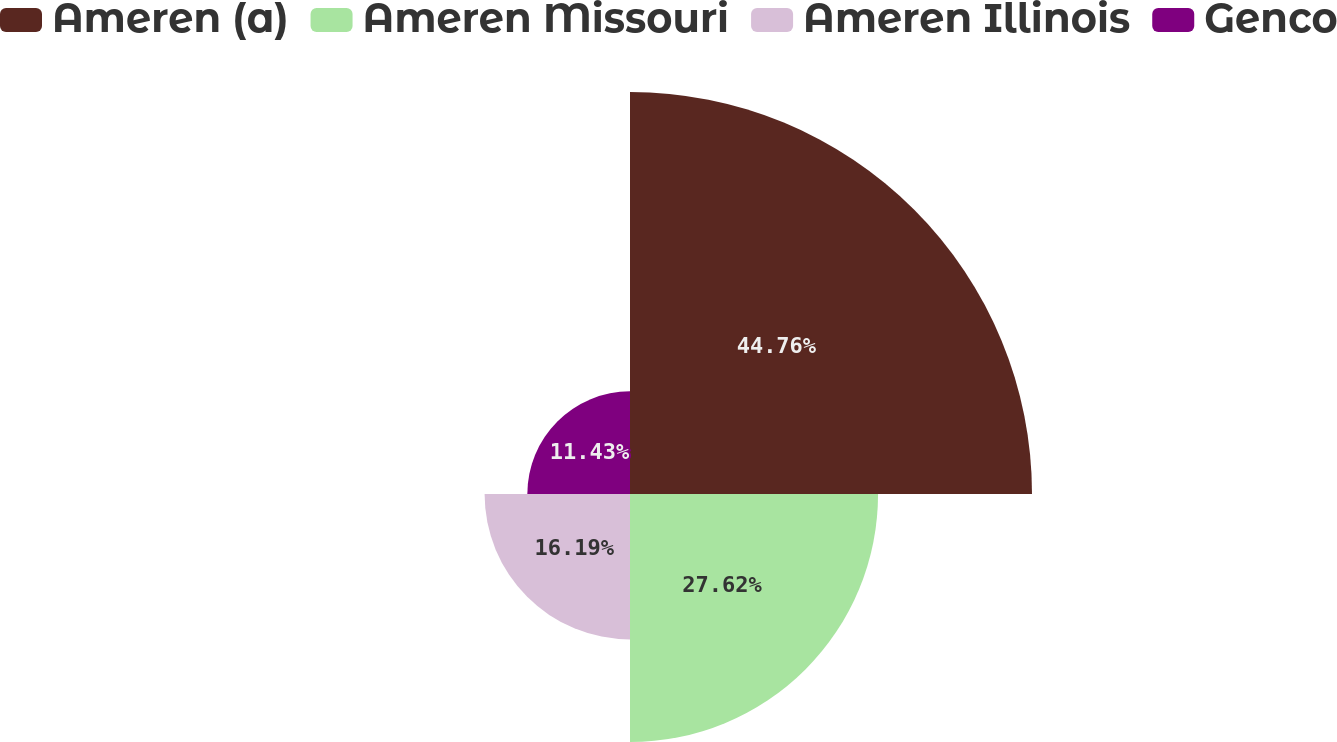<chart> <loc_0><loc_0><loc_500><loc_500><pie_chart><fcel>Ameren (a)<fcel>Ameren Missouri<fcel>Ameren Illinois<fcel>Genco<nl><fcel>44.76%<fcel>27.62%<fcel>16.19%<fcel>11.43%<nl></chart> 